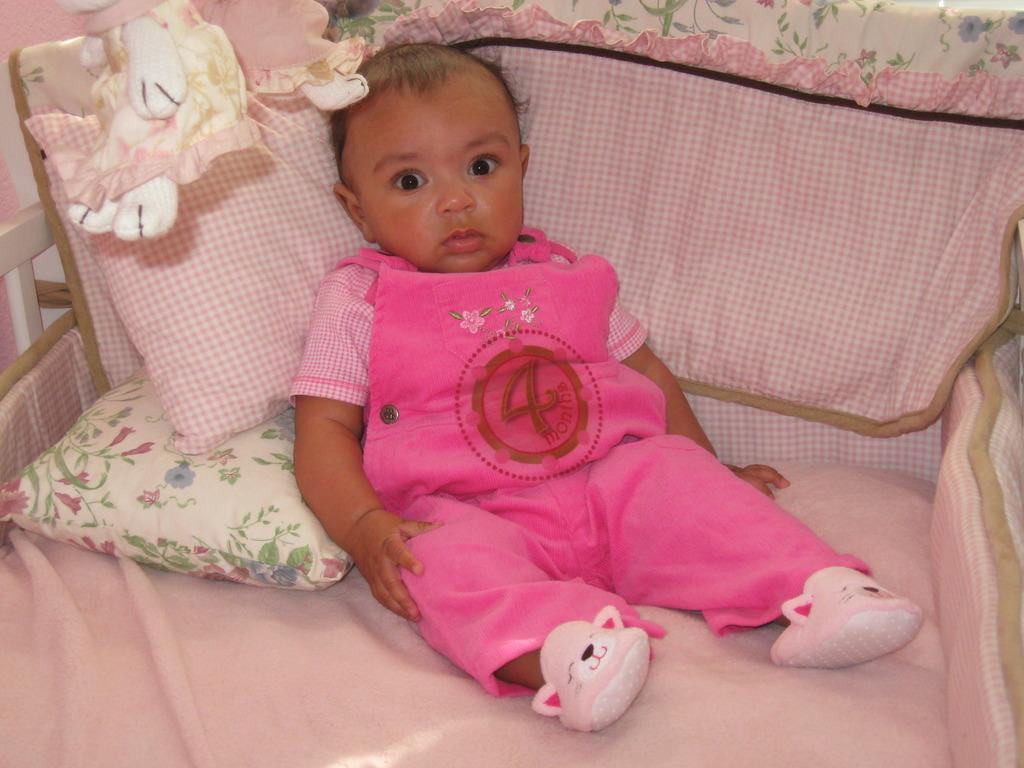What is the main subject of the image? There is a baby in the image. Where is the baby located? The baby is on a bed. What can be seen on the bed besides the baby? There are two pillows on the bed. What is the color of the bed sheet? The bed sheet is pink in color. What is the baby wearing? The baby is wearing a pink dress. What type of gate can be seen in the image? There is no gate present in the image. Can you describe the goose that is sitting next to the baby? There is no goose present in the image; the main subject is a baby on a bed. 